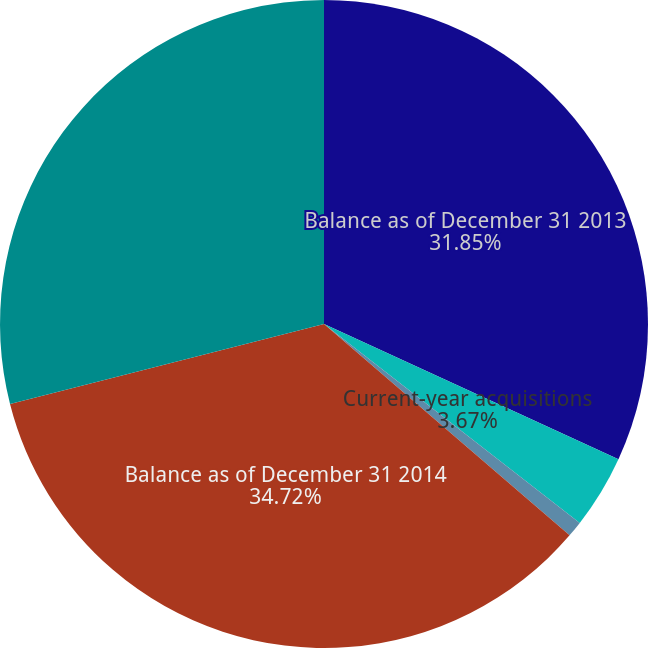<chart> <loc_0><loc_0><loc_500><loc_500><pie_chart><fcel>Balance as of December 31 2013<fcel>Current-year acquisitions<fcel>Foreign currency and other<fcel>Balance as of December 31 2014<fcel>Balance as of December 31 2015<nl><fcel>31.85%<fcel>3.67%<fcel>0.79%<fcel>34.72%<fcel>28.97%<nl></chart> 